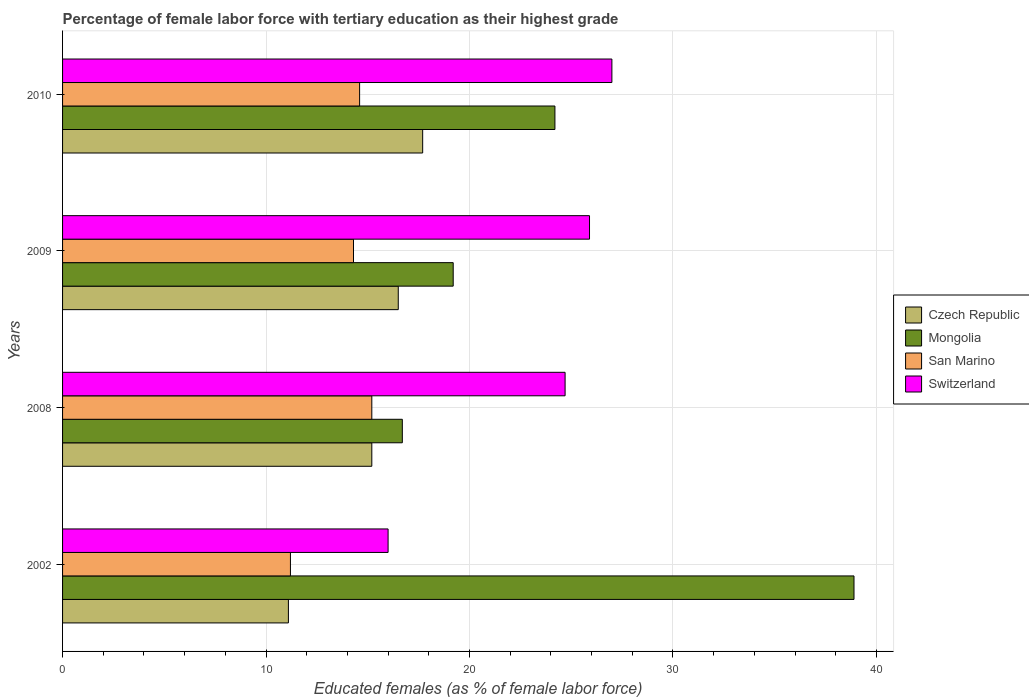Are the number of bars on each tick of the Y-axis equal?
Offer a very short reply. Yes. How many bars are there on the 2nd tick from the top?
Your answer should be very brief. 4. What is the percentage of female labor force with tertiary education in Czech Republic in 2010?
Ensure brevity in your answer.  17.7. Across all years, what is the maximum percentage of female labor force with tertiary education in Mongolia?
Make the answer very short. 38.9. Across all years, what is the minimum percentage of female labor force with tertiary education in Mongolia?
Provide a short and direct response. 16.7. In which year was the percentage of female labor force with tertiary education in San Marino maximum?
Your answer should be very brief. 2008. In which year was the percentage of female labor force with tertiary education in Czech Republic minimum?
Give a very brief answer. 2002. What is the total percentage of female labor force with tertiary education in Czech Republic in the graph?
Make the answer very short. 60.5. What is the difference between the percentage of female labor force with tertiary education in Switzerland in 2008 and that in 2009?
Offer a terse response. -1.2. What is the difference between the percentage of female labor force with tertiary education in Switzerland in 2010 and the percentage of female labor force with tertiary education in San Marino in 2009?
Give a very brief answer. 12.7. What is the average percentage of female labor force with tertiary education in Switzerland per year?
Ensure brevity in your answer.  23.4. In the year 2002, what is the difference between the percentage of female labor force with tertiary education in Mongolia and percentage of female labor force with tertiary education in Switzerland?
Provide a short and direct response. 22.9. What is the ratio of the percentage of female labor force with tertiary education in San Marino in 2002 to that in 2009?
Provide a short and direct response. 0.78. Is the percentage of female labor force with tertiary education in San Marino in 2008 less than that in 2009?
Make the answer very short. No. What is the difference between the highest and the second highest percentage of female labor force with tertiary education in San Marino?
Offer a terse response. 0.6. What is the difference between the highest and the lowest percentage of female labor force with tertiary education in Mongolia?
Your answer should be very brief. 22.2. Is the sum of the percentage of female labor force with tertiary education in Switzerland in 2002 and 2008 greater than the maximum percentage of female labor force with tertiary education in Czech Republic across all years?
Your answer should be compact. Yes. Is it the case that in every year, the sum of the percentage of female labor force with tertiary education in Mongolia and percentage of female labor force with tertiary education in San Marino is greater than the sum of percentage of female labor force with tertiary education in Czech Republic and percentage of female labor force with tertiary education in Switzerland?
Your answer should be compact. No. What does the 4th bar from the top in 2009 represents?
Provide a short and direct response. Czech Republic. What does the 4th bar from the bottom in 2002 represents?
Provide a succinct answer. Switzerland. Is it the case that in every year, the sum of the percentage of female labor force with tertiary education in Czech Republic and percentage of female labor force with tertiary education in Mongolia is greater than the percentage of female labor force with tertiary education in San Marino?
Offer a very short reply. Yes. How many bars are there?
Provide a succinct answer. 16. Are all the bars in the graph horizontal?
Keep it short and to the point. Yes. How many years are there in the graph?
Keep it short and to the point. 4. Does the graph contain any zero values?
Ensure brevity in your answer.  No. Does the graph contain grids?
Your response must be concise. Yes. Where does the legend appear in the graph?
Your answer should be very brief. Center right. How many legend labels are there?
Make the answer very short. 4. What is the title of the graph?
Give a very brief answer. Percentage of female labor force with tertiary education as their highest grade. Does "Tunisia" appear as one of the legend labels in the graph?
Your answer should be compact. No. What is the label or title of the X-axis?
Your answer should be very brief. Educated females (as % of female labor force). What is the Educated females (as % of female labor force) in Czech Republic in 2002?
Provide a succinct answer. 11.1. What is the Educated females (as % of female labor force) of Mongolia in 2002?
Your response must be concise. 38.9. What is the Educated females (as % of female labor force) in San Marino in 2002?
Provide a short and direct response. 11.2. What is the Educated females (as % of female labor force) in Czech Republic in 2008?
Give a very brief answer. 15.2. What is the Educated females (as % of female labor force) of Mongolia in 2008?
Ensure brevity in your answer.  16.7. What is the Educated females (as % of female labor force) of San Marino in 2008?
Provide a short and direct response. 15.2. What is the Educated females (as % of female labor force) of Switzerland in 2008?
Provide a short and direct response. 24.7. What is the Educated females (as % of female labor force) in Czech Republic in 2009?
Ensure brevity in your answer.  16.5. What is the Educated females (as % of female labor force) in Mongolia in 2009?
Provide a short and direct response. 19.2. What is the Educated females (as % of female labor force) of San Marino in 2009?
Provide a short and direct response. 14.3. What is the Educated females (as % of female labor force) of Switzerland in 2009?
Make the answer very short. 25.9. What is the Educated females (as % of female labor force) of Czech Republic in 2010?
Your answer should be compact. 17.7. What is the Educated females (as % of female labor force) of Mongolia in 2010?
Your answer should be very brief. 24.2. What is the Educated females (as % of female labor force) in San Marino in 2010?
Give a very brief answer. 14.6. Across all years, what is the maximum Educated females (as % of female labor force) of Czech Republic?
Your answer should be very brief. 17.7. Across all years, what is the maximum Educated females (as % of female labor force) of Mongolia?
Offer a terse response. 38.9. Across all years, what is the maximum Educated females (as % of female labor force) of San Marino?
Make the answer very short. 15.2. Across all years, what is the minimum Educated females (as % of female labor force) in Czech Republic?
Make the answer very short. 11.1. Across all years, what is the minimum Educated females (as % of female labor force) of Mongolia?
Provide a succinct answer. 16.7. Across all years, what is the minimum Educated females (as % of female labor force) in San Marino?
Your answer should be very brief. 11.2. Across all years, what is the minimum Educated females (as % of female labor force) of Switzerland?
Your answer should be compact. 16. What is the total Educated females (as % of female labor force) of Czech Republic in the graph?
Offer a terse response. 60.5. What is the total Educated females (as % of female labor force) in San Marino in the graph?
Your answer should be very brief. 55.3. What is the total Educated females (as % of female labor force) in Switzerland in the graph?
Provide a short and direct response. 93.6. What is the difference between the Educated females (as % of female labor force) in Mongolia in 2002 and that in 2008?
Provide a succinct answer. 22.2. What is the difference between the Educated females (as % of female labor force) in Czech Republic in 2002 and that in 2009?
Provide a succinct answer. -5.4. What is the difference between the Educated females (as % of female labor force) of San Marino in 2002 and that in 2009?
Keep it short and to the point. -3.1. What is the difference between the Educated females (as % of female labor force) in San Marino in 2002 and that in 2010?
Ensure brevity in your answer.  -3.4. What is the difference between the Educated females (as % of female labor force) of Czech Republic in 2008 and that in 2009?
Offer a terse response. -1.3. What is the difference between the Educated females (as % of female labor force) of Czech Republic in 2008 and that in 2010?
Keep it short and to the point. -2.5. What is the difference between the Educated females (as % of female labor force) of Czech Republic in 2009 and that in 2010?
Give a very brief answer. -1.2. What is the difference between the Educated females (as % of female labor force) of Mongolia in 2009 and that in 2010?
Ensure brevity in your answer.  -5. What is the difference between the Educated females (as % of female labor force) in Switzerland in 2009 and that in 2010?
Your answer should be compact. -1.1. What is the difference between the Educated females (as % of female labor force) in Czech Republic in 2002 and the Educated females (as % of female labor force) in Mongolia in 2008?
Your response must be concise. -5.6. What is the difference between the Educated females (as % of female labor force) of Czech Republic in 2002 and the Educated females (as % of female labor force) of San Marino in 2008?
Make the answer very short. -4.1. What is the difference between the Educated females (as % of female labor force) of Mongolia in 2002 and the Educated females (as % of female labor force) of San Marino in 2008?
Offer a terse response. 23.7. What is the difference between the Educated females (as % of female labor force) of San Marino in 2002 and the Educated females (as % of female labor force) of Switzerland in 2008?
Offer a terse response. -13.5. What is the difference between the Educated females (as % of female labor force) in Czech Republic in 2002 and the Educated females (as % of female labor force) in Switzerland in 2009?
Your response must be concise. -14.8. What is the difference between the Educated females (as % of female labor force) of Mongolia in 2002 and the Educated females (as % of female labor force) of San Marino in 2009?
Provide a succinct answer. 24.6. What is the difference between the Educated females (as % of female labor force) of San Marino in 2002 and the Educated females (as % of female labor force) of Switzerland in 2009?
Provide a succinct answer. -14.7. What is the difference between the Educated females (as % of female labor force) of Czech Republic in 2002 and the Educated females (as % of female labor force) of Mongolia in 2010?
Your answer should be compact. -13.1. What is the difference between the Educated females (as % of female labor force) in Czech Republic in 2002 and the Educated females (as % of female labor force) in San Marino in 2010?
Your answer should be very brief. -3.5. What is the difference between the Educated females (as % of female labor force) of Czech Republic in 2002 and the Educated females (as % of female labor force) of Switzerland in 2010?
Provide a succinct answer. -15.9. What is the difference between the Educated females (as % of female labor force) in Mongolia in 2002 and the Educated females (as % of female labor force) in San Marino in 2010?
Make the answer very short. 24.3. What is the difference between the Educated females (as % of female labor force) of Mongolia in 2002 and the Educated females (as % of female labor force) of Switzerland in 2010?
Your response must be concise. 11.9. What is the difference between the Educated females (as % of female labor force) in San Marino in 2002 and the Educated females (as % of female labor force) in Switzerland in 2010?
Make the answer very short. -15.8. What is the difference between the Educated females (as % of female labor force) of Czech Republic in 2008 and the Educated females (as % of female labor force) of San Marino in 2009?
Keep it short and to the point. 0.9. What is the difference between the Educated females (as % of female labor force) of Mongolia in 2008 and the Educated females (as % of female labor force) of San Marino in 2009?
Your answer should be compact. 2.4. What is the difference between the Educated females (as % of female labor force) in Czech Republic in 2008 and the Educated females (as % of female labor force) in Switzerland in 2010?
Offer a very short reply. -11.8. What is the difference between the Educated females (as % of female labor force) in Mongolia in 2008 and the Educated females (as % of female labor force) in Switzerland in 2010?
Provide a short and direct response. -10.3. What is the difference between the Educated females (as % of female labor force) in San Marino in 2008 and the Educated females (as % of female labor force) in Switzerland in 2010?
Your answer should be very brief. -11.8. What is the difference between the Educated females (as % of female labor force) of Czech Republic in 2009 and the Educated females (as % of female labor force) of Mongolia in 2010?
Provide a short and direct response. -7.7. What is the difference between the Educated females (as % of female labor force) in Mongolia in 2009 and the Educated females (as % of female labor force) in San Marino in 2010?
Keep it short and to the point. 4.6. What is the difference between the Educated females (as % of female labor force) in San Marino in 2009 and the Educated females (as % of female labor force) in Switzerland in 2010?
Provide a short and direct response. -12.7. What is the average Educated females (as % of female labor force) of Czech Republic per year?
Your answer should be very brief. 15.12. What is the average Educated females (as % of female labor force) in Mongolia per year?
Offer a terse response. 24.75. What is the average Educated females (as % of female labor force) of San Marino per year?
Your response must be concise. 13.82. What is the average Educated females (as % of female labor force) of Switzerland per year?
Offer a very short reply. 23.4. In the year 2002, what is the difference between the Educated females (as % of female labor force) of Czech Republic and Educated females (as % of female labor force) of Mongolia?
Your response must be concise. -27.8. In the year 2002, what is the difference between the Educated females (as % of female labor force) in Czech Republic and Educated females (as % of female labor force) in Switzerland?
Your answer should be very brief. -4.9. In the year 2002, what is the difference between the Educated females (as % of female labor force) in Mongolia and Educated females (as % of female labor force) in San Marino?
Keep it short and to the point. 27.7. In the year 2002, what is the difference between the Educated females (as % of female labor force) in Mongolia and Educated females (as % of female labor force) in Switzerland?
Your response must be concise. 22.9. In the year 2008, what is the difference between the Educated females (as % of female labor force) in Mongolia and Educated females (as % of female labor force) in San Marino?
Your answer should be very brief. 1.5. In the year 2008, what is the difference between the Educated females (as % of female labor force) in Mongolia and Educated females (as % of female labor force) in Switzerland?
Provide a succinct answer. -8. In the year 2009, what is the difference between the Educated females (as % of female labor force) in Czech Republic and Educated females (as % of female labor force) in Mongolia?
Provide a succinct answer. -2.7. In the year 2009, what is the difference between the Educated females (as % of female labor force) in Czech Republic and Educated females (as % of female labor force) in San Marino?
Provide a short and direct response. 2.2. In the year 2009, what is the difference between the Educated females (as % of female labor force) of Czech Republic and Educated females (as % of female labor force) of Switzerland?
Keep it short and to the point. -9.4. In the year 2009, what is the difference between the Educated females (as % of female labor force) of Mongolia and Educated females (as % of female labor force) of San Marino?
Make the answer very short. 4.9. In the year 2010, what is the difference between the Educated females (as % of female labor force) of Czech Republic and Educated females (as % of female labor force) of San Marino?
Ensure brevity in your answer.  3.1. In the year 2010, what is the difference between the Educated females (as % of female labor force) of Czech Republic and Educated females (as % of female labor force) of Switzerland?
Provide a succinct answer. -9.3. In the year 2010, what is the difference between the Educated females (as % of female labor force) of Mongolia and Educated females (as % of female labor force) of San Marino?
Your answer should be compact. 9.6. What is the ratio of the Educated females (as % of female labor force) of Czech Republic in 2002 to that in 2008?
Your response must be concise. 0.73. What is the ratio of the Educated females (as % of female labor force) of Mongolia in 2002 to that in 2008?
Ensure brevity in your answer.  2.33. What is the ratio of the Educated females (as % of female labor force) in San Marino in 2002 to that in 2008?
Your answer should be very brief. 0.74. What is the ratio of the Educated females (as % of female labor force) of Switzerland in 2002 to that in 2008?
Keep it short and to the point. 0.65. What is the ratio of the Educated females (as % of female labor force) in Czech Republic in 2002 to that in 2009?
Keep it short and to the point. 0.67. What is the ratio of the Educated females (as % of female labor force) of Mongolia in 2002 to that in 2009?
Provide a succinct answer. 2.03. What is the ratio of the Educated females (as % of female labor force) of San Marino in 2002 to that in 2009?
Offer a very short reply. 0.78. What is the ratio of the Educated females (as % of female labor force) of Switzerland in 2002 to that in 2009?
Offer a very short reply. 0.62. What is the ratio of the Educated females (as % of female labor force) in Czech Republic in 2002 to that in 2010?
Your answer should be compact. 0.63. What is the ratio of the Educated females (as % of female labor force) of Mongolia in 2002 to that in 2010?
Give a very brief answer. 1.61. What is the ratio of the Educated females (as % of female labor force) of San Marino in 2002 to that in 2010?
Offer a terse response. 0.77. What is the ratio of the Educated females (as % of female labor force) in Switzerland in 2002 to that in 2010?
Make the answer very short. 0.59. What is the ratio of the Educated females (as % of female labor force) of Czech Republic in 2008 to that in 2009?
Give a very brief answer. 0.92. What is the ratio of the Educated females (as % of female labor force) of Mongolia in 2008 to that in 2009?
Make the answer very short. 0.87. What is the ratio of the Educated females (as % of female labor force) of San Marino in 2008 to that in 2009?
Give a very brief answer. 1.06. What is the ratio of the Educated females (as % of female labor force) in Switzerland in 2008 to that in 2009?
Provide a short and direct response. 0.95. What is the ratio of the Educated females (as % of female labor force) of Czech Republic in 2008 to that in 2010?
Offer a very short reply. 0.86. What is the ratio of the Educated females (as % of female labor force) of Mongolia in 2008 to that in 2010?
Offer a terse response. 0.69. What is the ratio of the Educated females (as % of female labor force) in San Marino in 2008 to that in 2010?
Make the answer very short. 1.04. What is the ratio of the Educated females (as % of female labor force) of Switzerland in 2008 to that in 2010?
Provide a short and direct response. 0.91. What is the ratio of the Educated females (as % of female labor force) in Czech Republic in 2009 to that in 2010?
Ensure brevity in your answer.  0.93. What is the ratio of the Educated females (as % of female labor force) in Mongolia in 2009 to that in 2010?
Offer a very short reply. 0.79. What is the ratio of the Educated females (as % of female labor force) of San Marino in 2009 to that in 2010?
Ensure brevity in your answer.  0.98. What is the ratio of the Educated females (as % of female labor force) of Switzerland in 2009 to that in 2010?
Provide a short and direct response. 0.96. What is the difference between the highest and the lowest Educated females (as % of female labor force) in Mongolia?
Your answer should be compact. 22.2. What is the difference between the highest and the lowest Educated females (as % of female labor force) of San Marino?
Offer a very short reply. 4. 